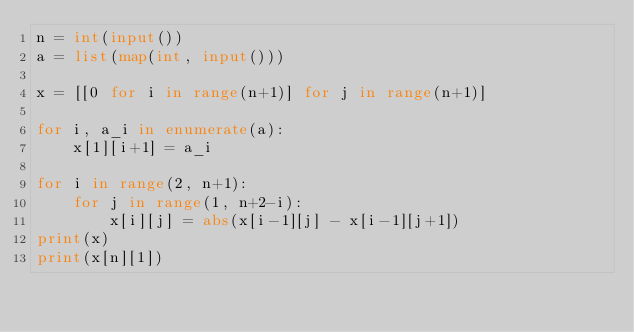Convert code to text. <code><loc_0><loc_0><loc_500><loc_500><_Python_>n = int(input())
a = list(map(int, input()))

x = [[0 for i in range(n+1)] for j in range(n+1)]

for i, a_i in enumerate(a):
	x[1][i+1] = a_i

for i in range(2, n+1):
	for j in range(1, n+2-i):
		x[i][j] = abs(x[i-1][j] - x[i-1][j+1])
print(x)
print(x[n][1])</code> 